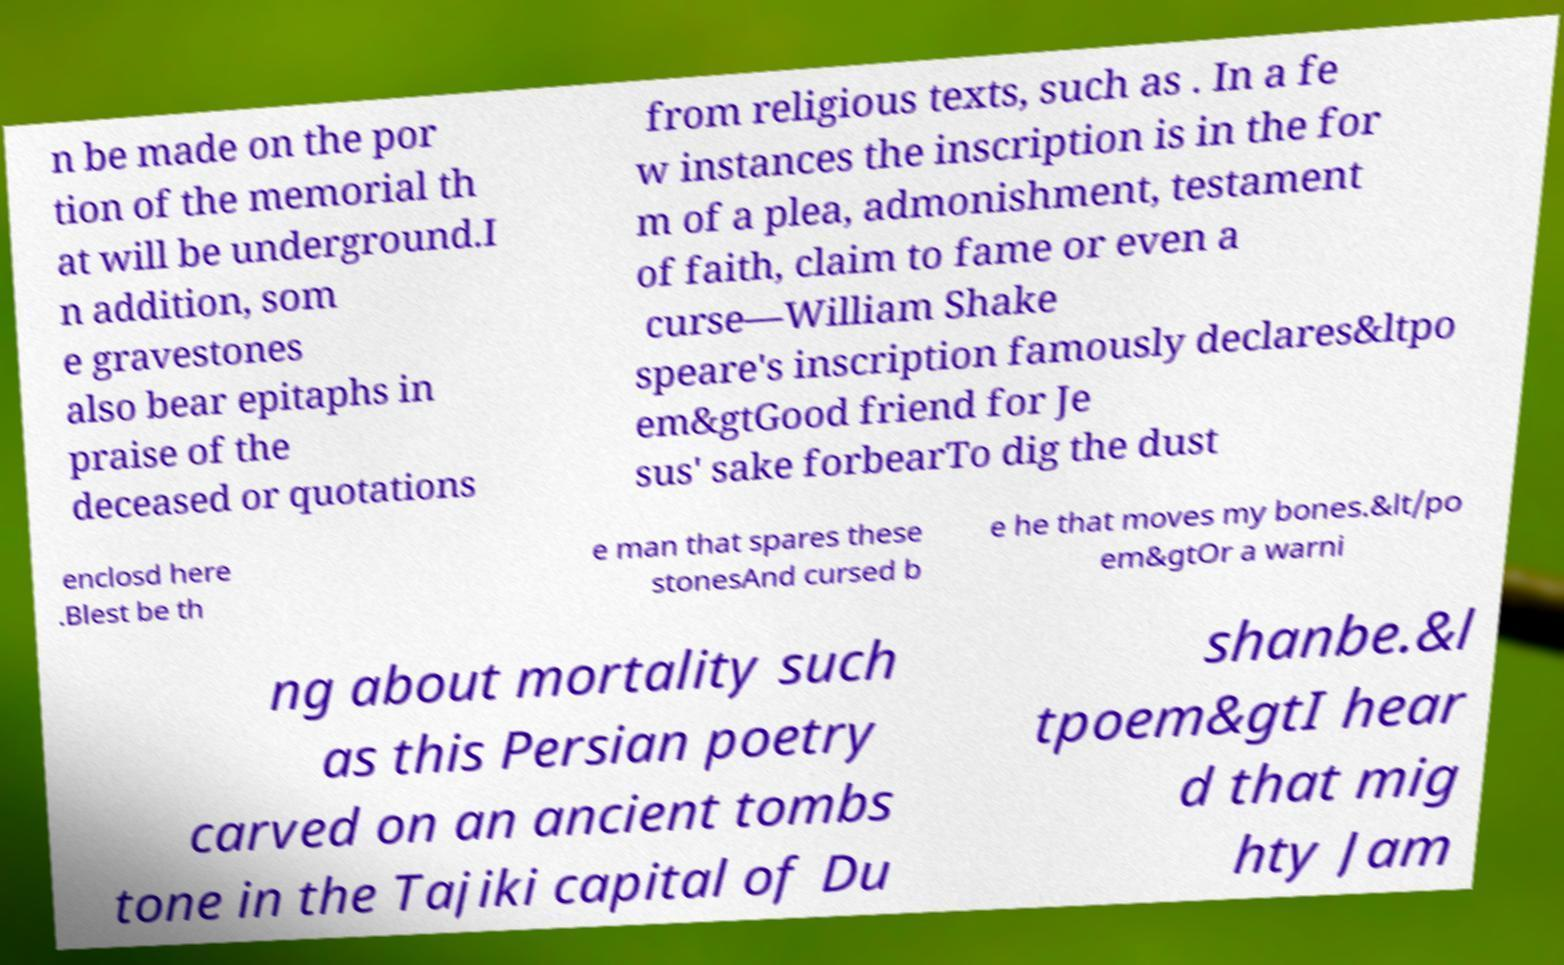Could you assist in decoding the text presented in this image and type it out clearly? n be made on the por tion of the memorial th at will be underground.I n addition, som e gravestones also bear epitaphs in praise of the deceased or quotations from religious texts, such as . In a fe w instances the inscription is in the for m of a plea, admonishment, testament of faith, claim to fame or even a curse—William Shake speare's inscription famously declares&ltpo em&gtGood friend for Je sus' sake forbearTo dig the dust enclosd here .Blest be th e man that spares these stonesAnd cursed b e he that moves my bones.&lt/po em&gtOr a warni ng about mortality such as this Persian poetry carved on an ancient tombs tone in the Tajiki capital of Du shanbe.&l tpoem&gtI hear d that mig hty Jam 